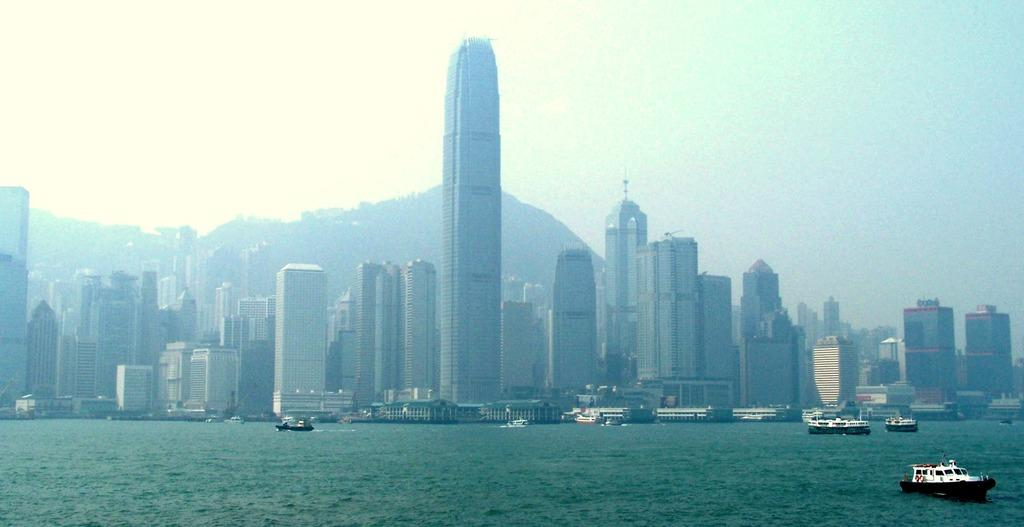What can be seen at the bottom of the image? There are ships on the water at the bottom side of the image. What type of buildings are in the center of the image? There are skyscrapers in the center of the image. What is located in the background of the image? It appears there is a mountain in the background. What is visible in the sky in the image? The sky is visible in the background of the image. Where is the ornament located in the image? There is no ornament present in the image. Is there a birthday celebration happening in the image? There is no indication of a birthday celebration in the image. 